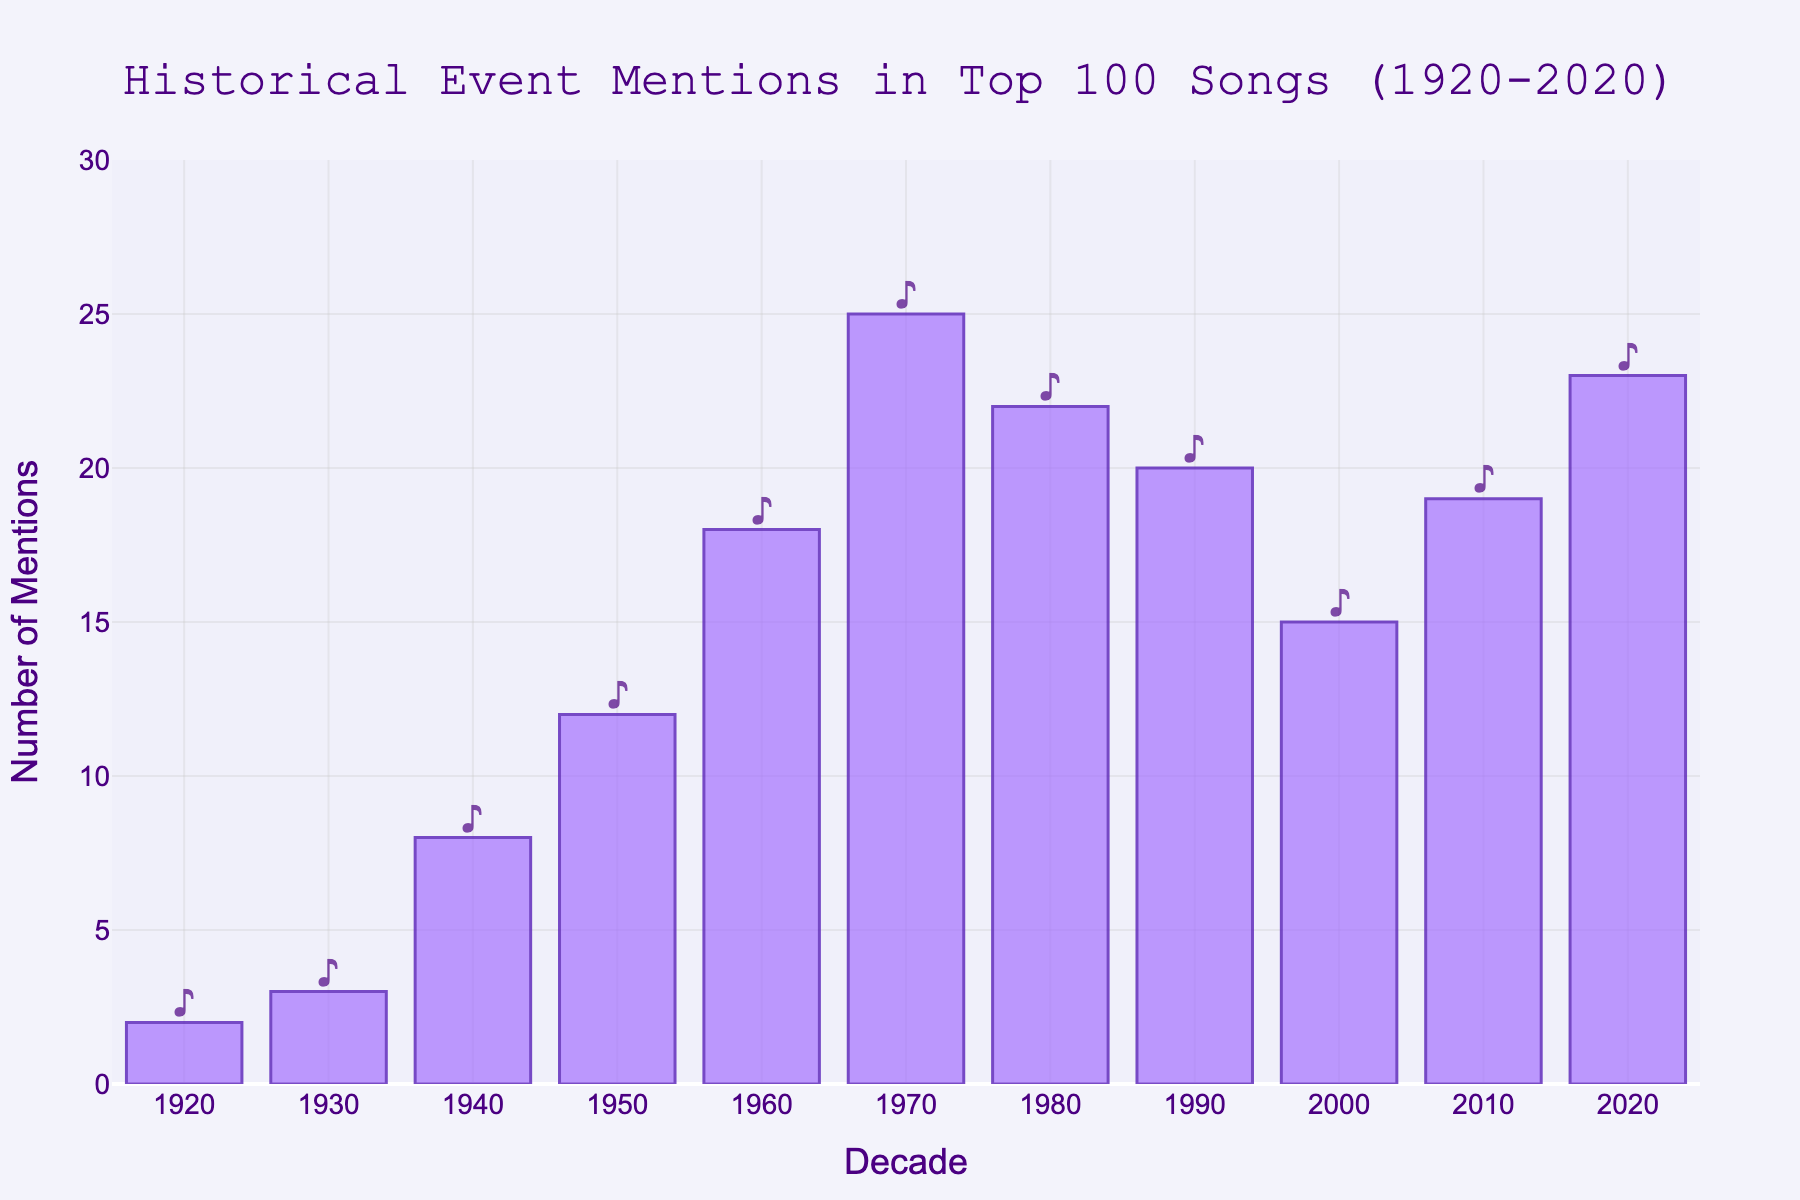What's the decade with the highest number of historical event mentions in top 100 songs? Identify the decade with the tallest bar in the chart, which represents the highest number of mentions. The decade 1970 has the tallest bar.
Answer: 1970 How many more historical event mentions were there in 1970 compared to 1950? Find the number of mentions in 1970 (25) and in 1950 (12), then subtract the latter from the former: 25 - 12 = 13.
Answer: 13 What is the average number of historical event mentions per decade from 1920 to 2020? Sum the number of mentions for all decades and divide by the number of decades. (2 + 3 + 8 + 12 + 18 + 25 + 22 + 20 + 15 + 19 + 23) = 167. There are 11 decades, so the average is 167 / 11 ≈ 15.18.
Answer: 15.18 Which decades have the same number of historical event mentions? Look for bars of the same height in the chart: the decades 1990 and 2010 both have 20 mentions.
Answer: 1990 and 2010 Did the number of historical event mentions increase or decrease from 2000 to 2010? Compare the heights of the bars for 2000 and 2010. The bar for 2010 (19) is taller than the bar for 2000 (15), indicating an increase.
Answer: Increase What's the total number of historical event mentions for the 1940s and 1980s combined? Add the number of mentions in 1940 (8) and 1980 (22): 8 + 22 = 30.
Answer: 30 Which decade had the lowest number of historical event mentions and how many were there? Identify the shortest bar in the chart and read its value. The decade 1920 has the shortest bar with 2 mentions.
Answer: 1920, 2 What’s the difference in historical event mentions between the decade with the highest mentions and the decade with the lowest mentions? Find the highest number of mentions (1970 with 25) and the lowest number (1920 with 2), then subtract the latter from the former: 25 - 2 = 23.
Answer: 23 What is the combined total of mentions in the first two decades of the century (2000 and 2010)? Add the number of mentions for 2000 (15) and 2010 (19): 15 + 19 = 34.
Answer: 34 